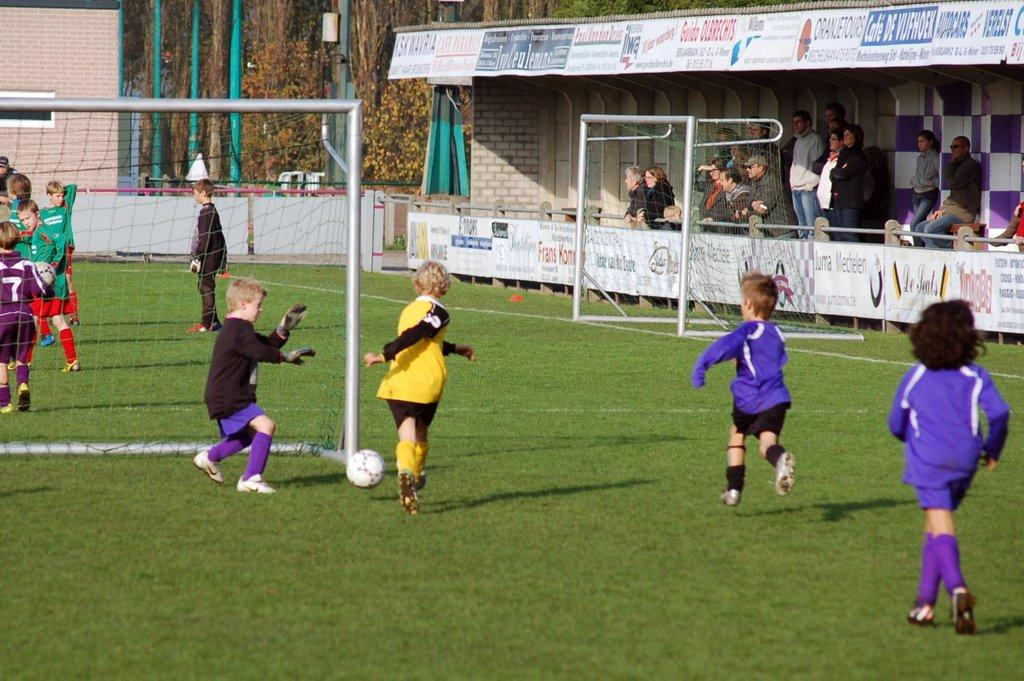<image>
Give a short and clear explanation of the subsequent image. a goalie that is wearing the number 7 